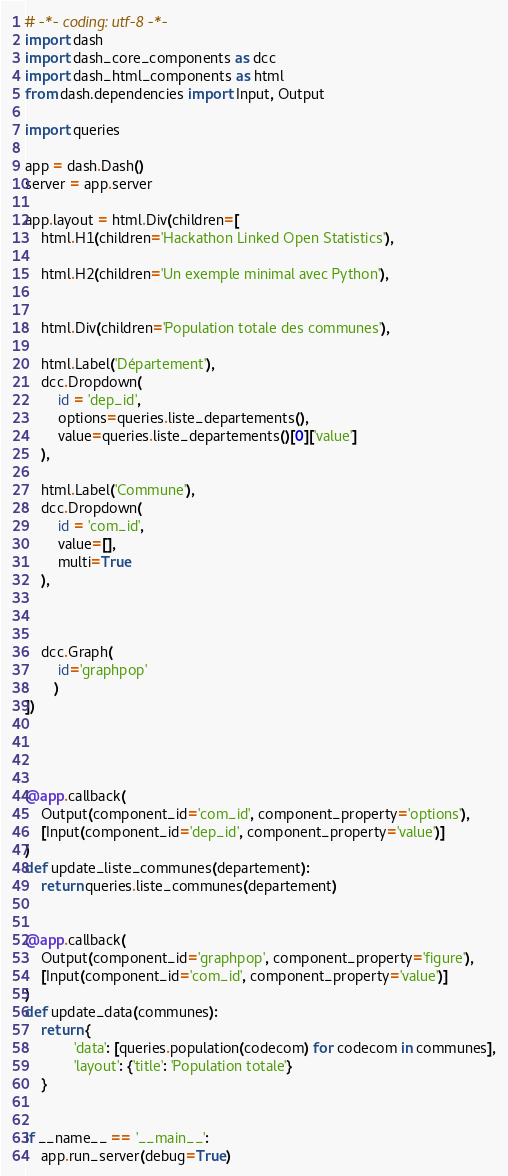<code> <loc_0><loc_0><loc_500><loc_500><_Python_># -*- coding: utf-8 -*-
import dash
import dash_core_components as dcc
import dash_html_components as html
from dash.dependencies import Input, Output

import queries

app = dash.Dash()
server = app.server

app.layout = html.Div(children=[
    html.H1(children='Hackathon Linked Open Statistics'),

    html.H2(children='Un exemple minimal avec Python'),
  

    html.Div(children='Population totale des communes'),

    html.Label('Département'),
    dcc.Dropdown(
        id = 'dep_id',
        options=queries.liste_departements(),
        value=queries.liste_departements()[0]['value']
    ),

    html.Label('Commune'),
    dcc.Dropdown(
        id = 'com_id',
        value=[],
        multi=True
    ),

    

    dcc.Graph(
        id='graphpop'
       )
])




@app.callback(
    Output(component_id='com_id', component_property='options'),
    [Input(component_id='dep_id', component_property='value')]
)
def update_liste_communes(departement):
    return queries.liste_communes(departement)


@app.callback(
    Output(component_id='graphpop', component_property='figure'),
    [Input(component_id='com_id', component_property='value')]
)
def update_data(communes):
    return {
            'data': [queries.population(codecom) for codecom in communes],
            'layout': {'title': 'Population totale'}
    }
    

if __name__ == '__main__':
    app.run_server(debug=True)</code> 